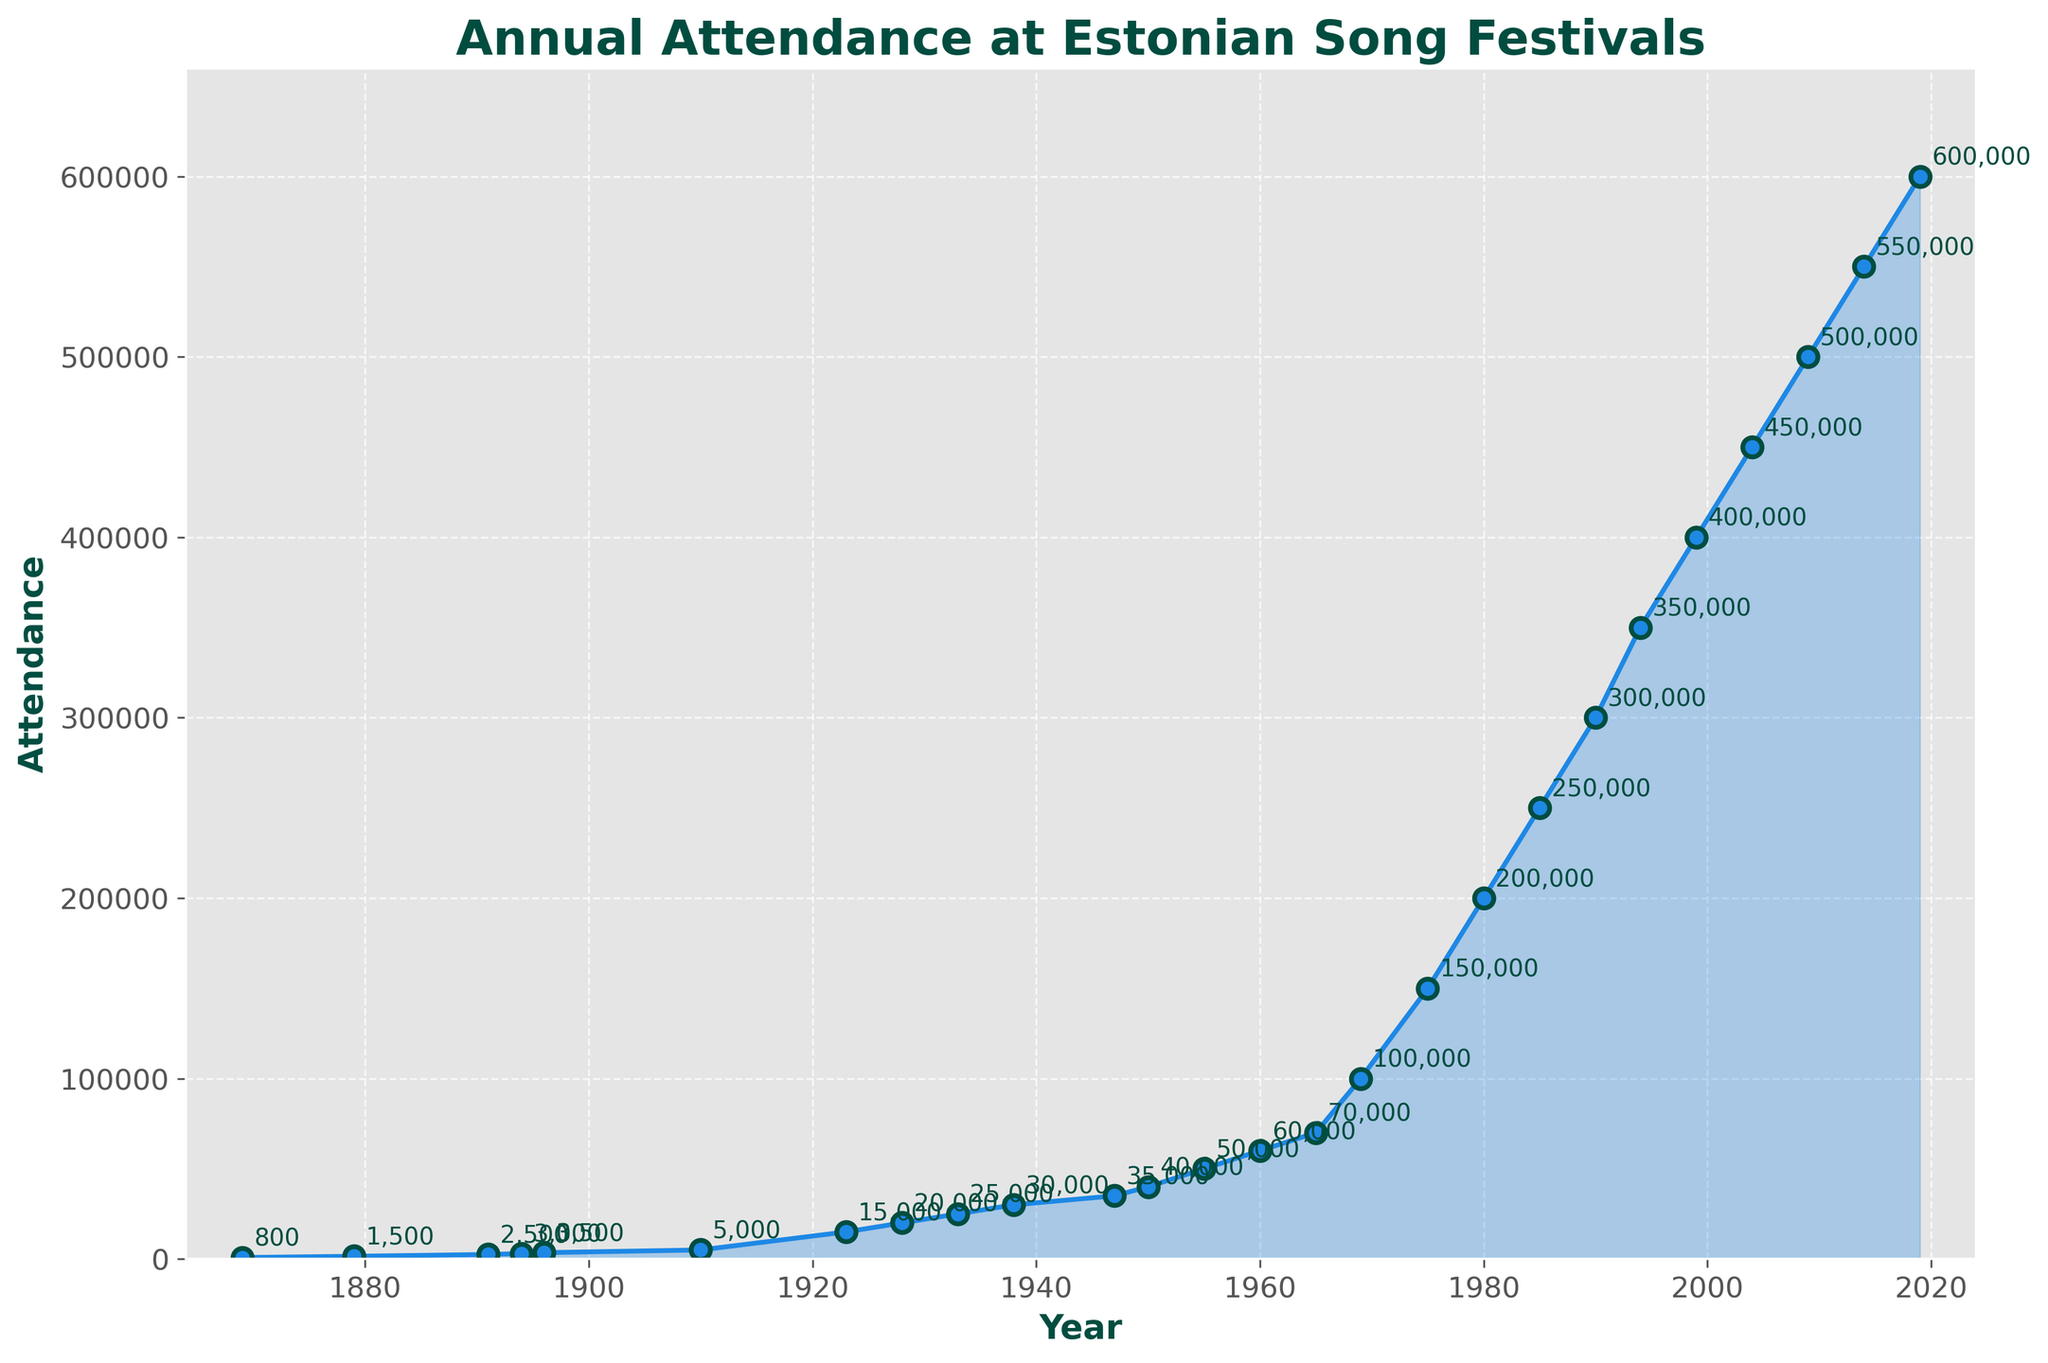What was the attendance at the Estonian Song Festival in 1869? Look at the data point corresponding to the year 1869. The figure indicates the attendance is marked by a dot and annotated with the value.
Answer: 800 By how much did the attendance increase from 1923 to 1938? Identify the attendance values for 1923 (15,000) and 1938 (30,000). Subtract the earlier value from the latter to find the increase: 30,000 - 15,000 = 15,000.
Answer: 15,000 In which year did the attendance first reach or exceed 200,000? Look at the annotated values following the trend line. 200,000 first appears in 1980.
Answer: 1980 How much higher is the attendance in 2019 compared to 1969? Locate the attendance values for the years 2019 and 1969. Subtract the 1969 value from the 2019 value: 600,000 - 100,000 = 500,000.
Answer: 500,000 When did the attendance exceed 50,000 for the first time? Find the year annotation where the attendance value rises above 50,000. This first occurs in 1955.
Answer: 1955 Which period shows the largest single increase in attendance within one interval? Compare the intervals between yearly attendance values. The largest increase happens between 1994 (350,000) and 1999 (400,000), which is a 50,000 increase.
Answer: 1994 to 1999 What’s the difference in attendance between the highest and lowest recorded values? Identify the highest (2019, 600,000) and the lowest attendance (1869, 800). Subtract the smallest from the largest: 600,000 - 800 = 599,200.
Answer: 599,200 Between which two consecutive Song Festivals did the attendance grow the most rapidly? Find the interval with the highest growth by comparing consecutive attendance records. The most rapid growth appears between 1965 (70,000) and 1969 (100,000), a difference of 30,000.
Answer: 1965 to 1969 Did any year see an unchanged attendance value compared to the previous festival? Inspect the consecutive data points. Each point shows an increase, meaning no year had unchanged attendance compared to the previous year.
Answer: No During which centuries did the largest single increase in attendance occur? Considering the century marks, the largest single increase spans the 20th century, especially visible around mid-century to later years.
Answer: 20th Century 